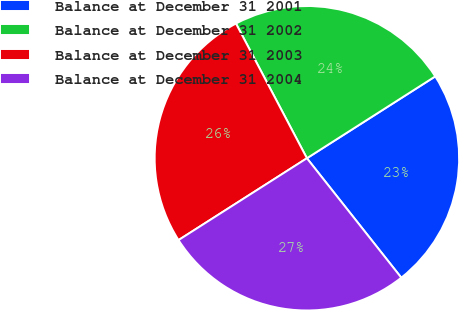Convert chart to OTSL. <chart><loc_0><loc_0><loc_500><loc_500><pie_chart><fcel>Balance at December 31 2001<fcel>Balance at December 31 2002<fcel>Balance at December 31 2003<fcel>Balance at December 31 2004<nl><fcel>23.39%<fcel>23.68%<fcel>26.32%<fcel>26.61%<nl></chart> 